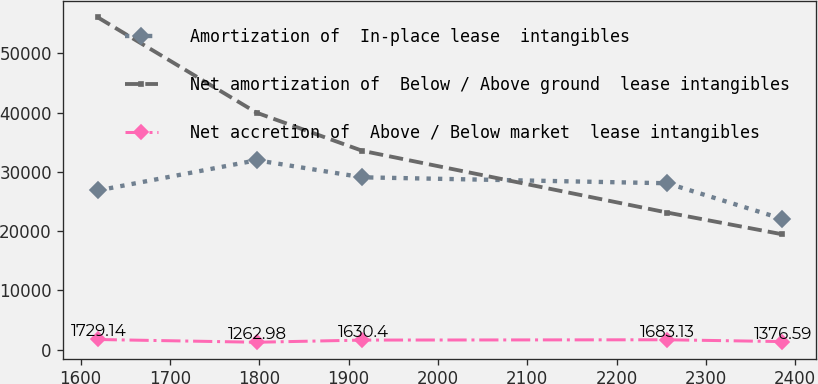<chart> <loc_0><loc_0><loc_500><loc_500><line_chart><ecel><fcel>Amortization of  In-place lease  intangibles<fcel>Net amortization of  Below / Above ground  lease intangibles<fcel>Net accretion of  Above / Below market  lease intangibles<nl><fcel>1619.17<fcel>26853.8<fcel>56052.2<fcel>1729.14<nl><fcel>1797.09<fcel>31957.5<fcel>39968.2<fcel>1262.98<nl><fcel>1915.39<fcel>29076<fcel>33543.8<fcel>1630.4<nl><fcel>2256.55<fcel>28075.1<fcel>23136.5<fcel>1683.13<nl><fcel>2385.18<fcel>22080.6<fcel>19479.2<fcel>1376.59<nl></chart> 